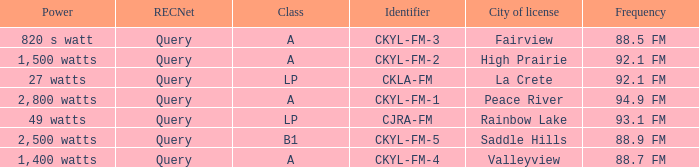What is the frequency that has a fairview city of license 88.5 FM. 